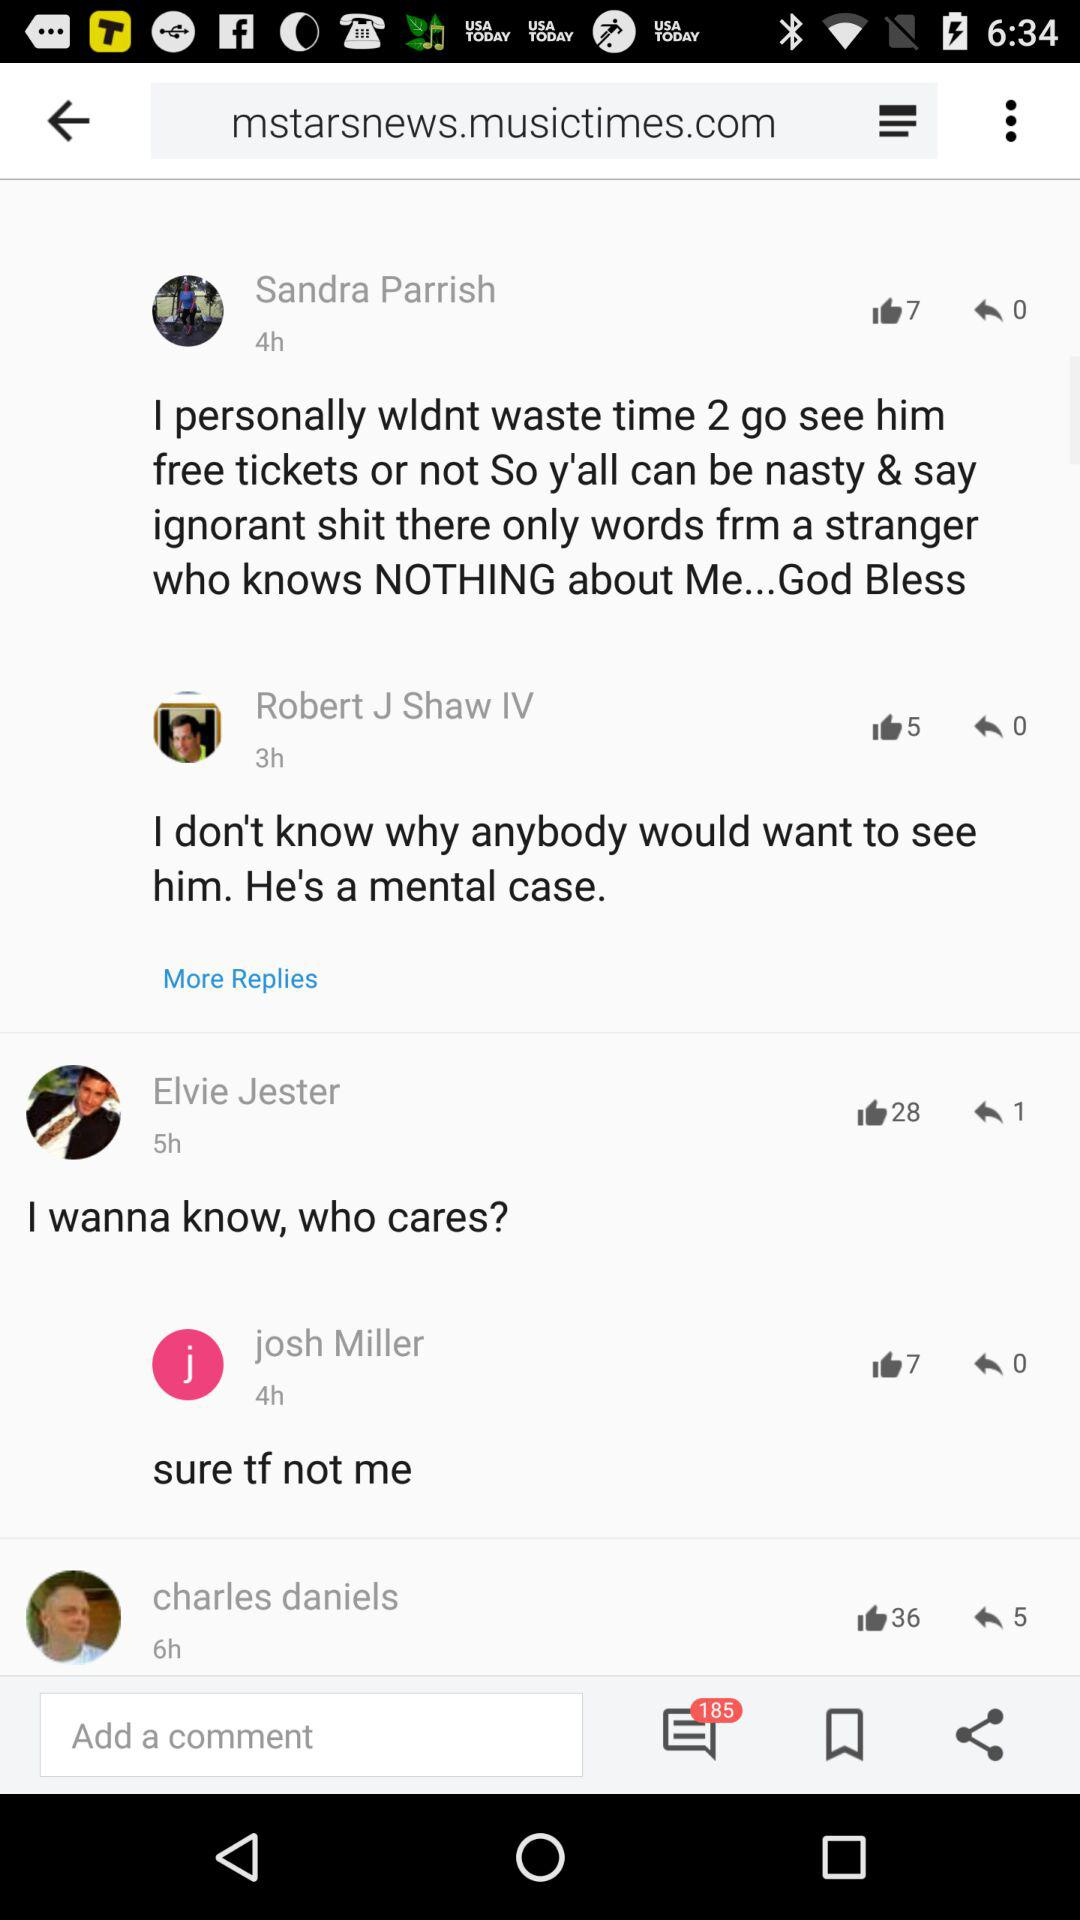What's the number of likes on the post by Elvie Jester? The number of likes on the post by Elvie Jester is 28. 